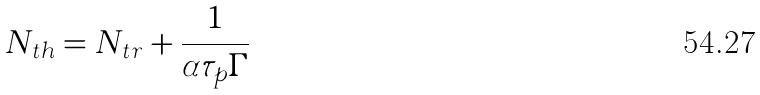Convert formula to latex. <formula><loc_0><loc_0><loc_500><loc_500>N _ { t h } = N _ { t r } + \frac { 1 } { \alpha \tau _ { p } \Gamma }</formula> 